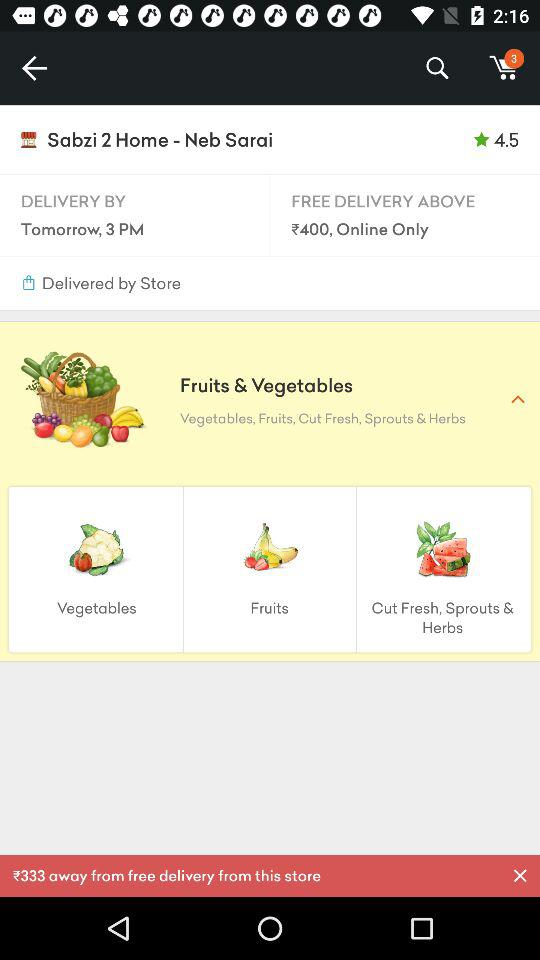What is the star rating of "Sabzi 2 Home-Neb Sarai"? The rating of "Sabzi 2 Home-Neb Sarai" is 4.5 stars. 